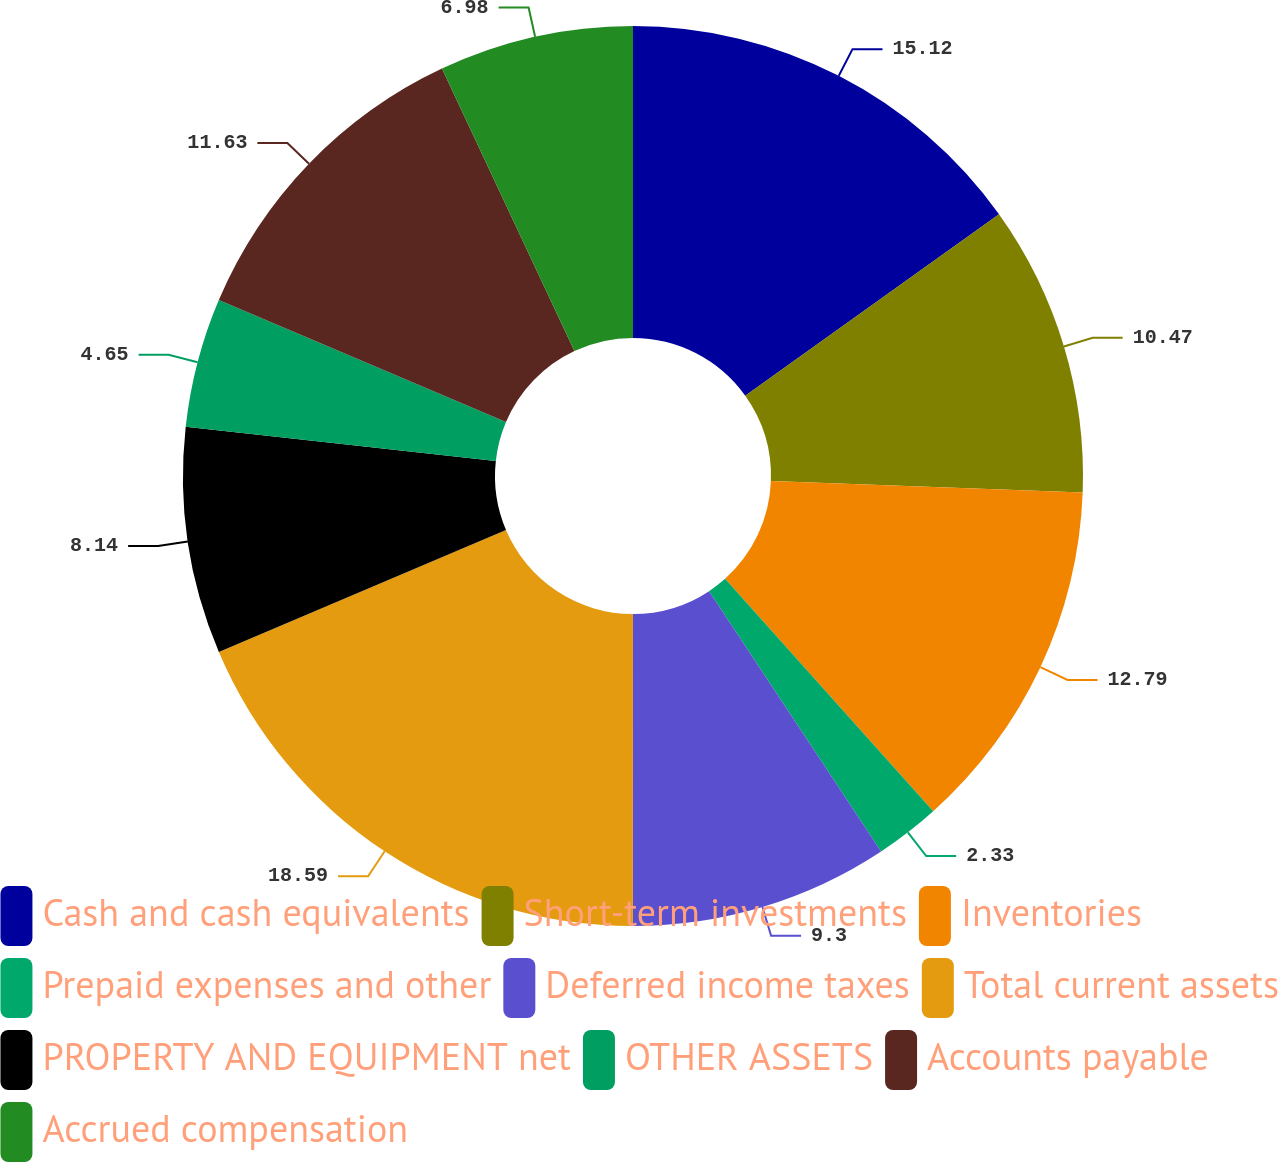Convert chart to OTSL. <chart><loc_0><loc_0><loc_500><loc_500><pie_chart><fcel>Cash and cash equivalents<fcel>Short-term investments<fcel>Inventories<fcel>Prepaid expenses and other<fcel>Deferred income taxes<fcel>Total current assets<fcel>PROPERTY AND EQUIPMENT net<fcel>OTHER ASSETS<fcel>Accounts payable<fcel>Accrued compensation<nl><fcel>15.12%<fcel>10.47%<fcel>12.79%<fcel>2.33%<fcel>9.3%<fcel>18.6%<fcel>8.14%<fcel>4.65%<fcel>11.63%<fcel>6.98%<nl></chart> 